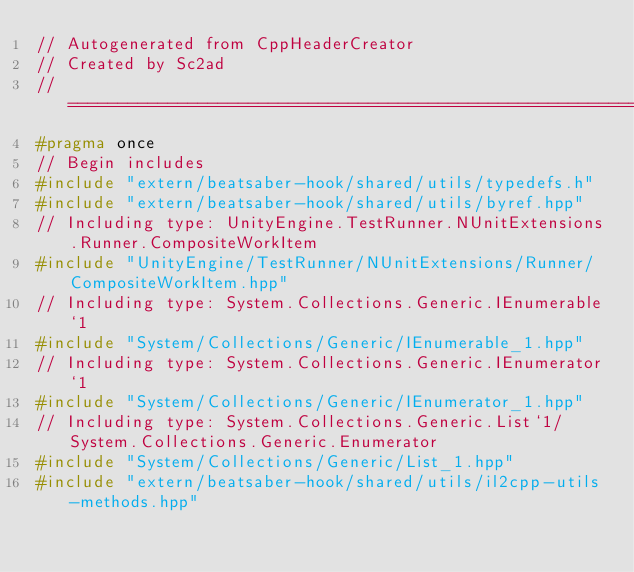<code> <loc_0><loc_0><loc_500><loc_500><_C++_>// Autogenerated from CppHeaderCreator
// Created by Sc2ad
// =========================================================================
#pragma once
// Begin includes
#include "extern/beatsaber-hook/shared/utils/typedefs.h"
#include "extern/beatsaber-hook/shared/utils/byref.hpp"
// Including type: UnityEngine.TestRunner.NUnitExtensions.Runner.CompositeWorkItem
#include "UnityEngine/TestRunner/NUnitExtensions/Runner/CompositeWorkItem.hpp"
// Including type: System.Collections.Generic.IEnumerable`1
#include "System/Collections/Generic/IEnumerable_1.hpp"
// Including type: System.Collections.Generic.IEnumerator`1
#include "System/Collections/Generic/IEnumerator_1.hpp"
// Including type: System.Collections.Generic.List`1/System.Collections.Generic.Enumerator
#include "System/Collections/Generic/List_1.hpp"
#include "extern/beatsaber-hook/shared/utils/il2cpp-utils-methods.hpp"</code> 